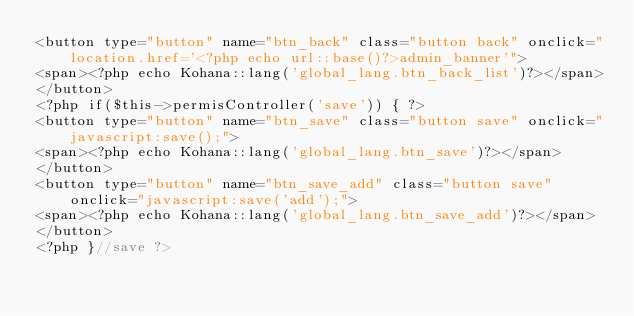Convert code to text. <code><loc_0><loc_0><loc_500><loc_500><_PHP_><button type="button" name="btn_back" class="button back" onclick="location.href='<?php echo url::base()?>admin_banner'">
<span><?php echo Kohana::lang('global_lang.btn_back_list')?></span>
</button>
<?php if($this->permisController('save')) { ?>
<button type="button" name="btn_save" class="button save" onclick="javascript:save();">
<span><?php echo Kohana::lang('global_lang.btn_save')?></span>
</button>        
<button type="button" name="btn_save_add" class="button save" onclick="javascript:save('add');">
<span><?php echo Kohana::lang('global_lang.btn_save_add')?></span>
</button>
<?php }//save ?></code> 